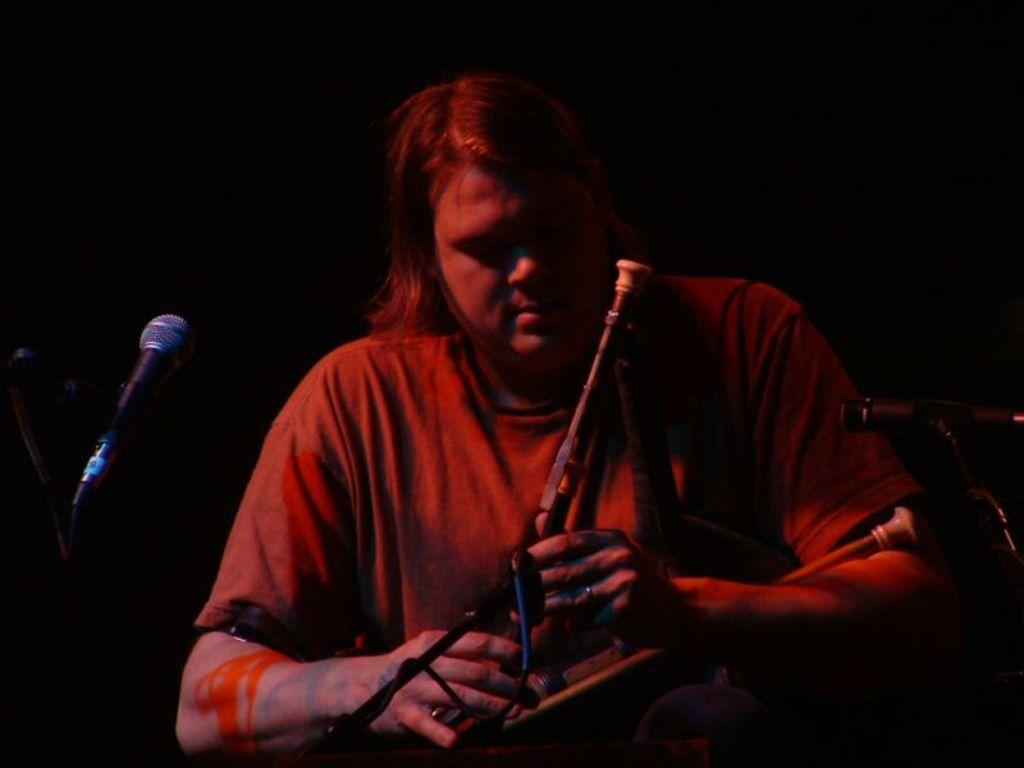What is the main subject of the image? There is a person in the image. What is the person holding in the image? The person is holding a musical instrument. What can be seen on the right side of the image? There is a stand on the right side of the image. What is present on the left side of the image? There is a microphone (mic) on the left side of the image. How much liquid is present in the image? There is no liquid present in the image. Can you see any signs of burning in the image? There are no signs of burning in the image. 